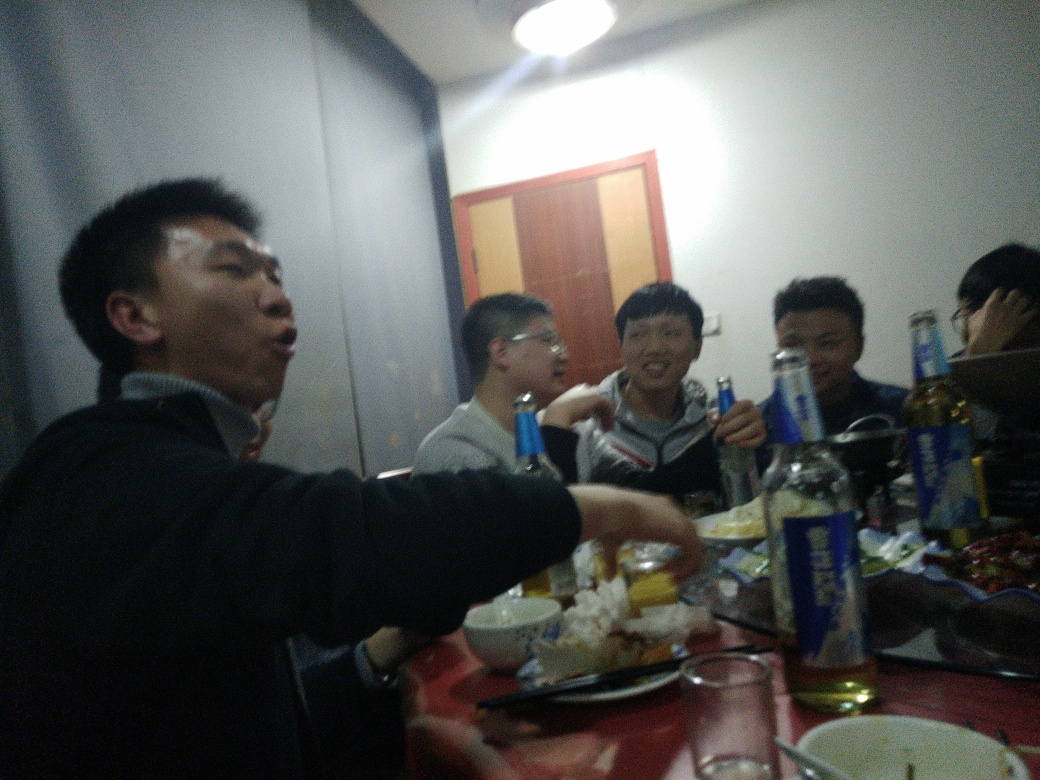What could be the cause of the red eye seen in one of the individuals? The red eye effect is usually caused by the camera flash bouncing off the retinas in the eyes of the subject due to the dilated pupils, often occurring in low-light conditions where pupils are more open to let in more light. 